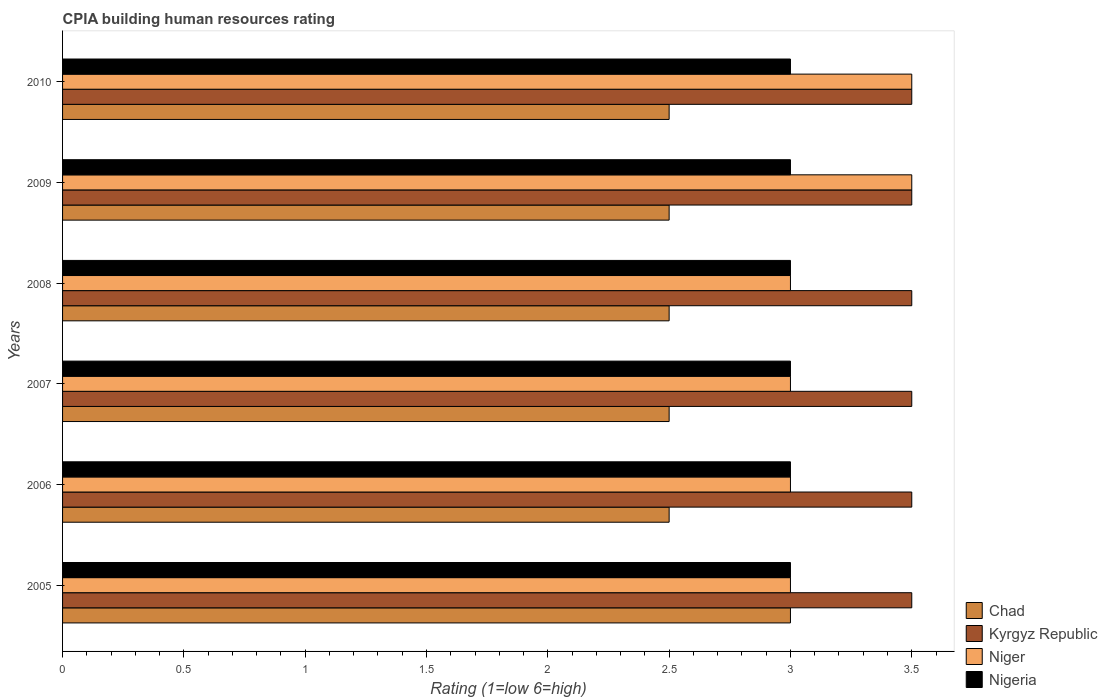How many groups of bars are there?
Ensure brevity in your answer.  6. Are the number of bars on each tick of the Y-axis equal?
Ensure brevity in your answer.  Yes. How many bars are there on the 6th tick from the top?
Provide a short and direct response. 4. In how many cases, is the number of bars for a given year not equal to the number of legend labels?
Offer a terse response. 0. What is the difference between the CPIA rating in Nigeria in 2009 and that in 2010?
Your answer should be compact. 0. What is the difference between the CPIA rating in Nigeria in 2010 and the CPIA rating in Kyrgyz Republic in 2008?
Make the answer very short. -0.5. In the year 2010, what is the difference between the CPIA rating in Niger and CPIA rating in Chad?
Provide a short and direct response. 1. In how many years, is the CPIA rating in Kyrgyz Republic greater than 0.8 ?
Offer a very short reply. 6. What is the ratio of the CPIA rating in Chad in 2005 to that in 2006?
Offer a very short reply. 1.2. What is the difference between the highest and the second highest CPIA rating in Niger?
Your answer should be compact. 0. What is the difference between the highest and the lowest CPIA rating in Niger?
Your answer should be very brief. 0.5. In how many years, is the CPIA rating in Nigeria greater than the average CPIA rating in Nigeria taken over all years?
Offer a very short reply. 0. Is the sum of the CPIA rating in Kyrgyz Republic in 2006 and 2008 greater than the maximum CPIA rating in Nigeria across all years?
Your response must be concise. Yes. Is it the case that in every year, the sum of the CPIA rating in Chad and CPIA rating in Niger is greater than the sum of CPIA rating in Kyrgyz Republic and CPIA rating in Nigeria?
Keep it short and to the point. Yes. What does the 1st bar from the top in 2005 represents?
Make the answer very short. Nigeria. What does the 2nd bar from the bottom in 2008 represents?
Your response must be concise. Kyrgyz Republic. How many bars are there?
Keep it short and to the point. 24. How many years are there in the graph?
Ensure brevity in your answer.  6. Where does the legend appear in the graph?
Give a very brief answer. Bottom right. What is the title of the graph?
Your response must be concise. CPIA building human resources rating. Does "Haiti" appear as one of the legend labels in the graph?
Provide a succinct answer. No. What is the label or title of the X-axis?
Provide a short and direct response. Rating (1=low 6=high). What is the label or title of the Y-axis?
Ensure brevity in your answer.  Years. What is the Rating (1=low 6=high) of Kyrgyz Republic in 2005?
Keep it short and to the point. 3.5. What is the Rating (1=low 6=high) of Kyrgyz Republic in 2006?
Your answer should be very brief. 3.5. What is the Rating (1=low 6=high) of Chad in 2007?
Your answer should be very brief. 2.5. What is the Rating (1=low 6=high) of Niger in 2007?
Offer a terse response. 3. What is the Rating (1=low 6=high) of Nigeria in 2009?
Provide a succinct answer. 3. What is the Rating (1=low 6=high) of Chad in 2010?
Ensure brevity in your answer.  2.5. What is the Rating (1=low 6=high) in Kyrgyz Republic in 2010?
Your answer should be compact. 3.5. Across all years, what is the maximum Rating (1=low 6=high) of Niger?
Make the answer very short. 3.5. Across all years, what is the minimum Rating (1=low 6=high) in Kyrgyz Republic?
Give a very brief answer. 3.5. Across all years, what is the minimum Rating (1=low 6=high) in Niger?
Your answer should be very brief. 3. Across all years, what is the minimum Rating (1=low 6=high) of Nigeria?
Make the answer very short. 3. What is the total Rating (1=low 6=high) of Niger in the graph?
Offer a terse response. 19. What is the difference between the Rating (1=low 6=high) in Chad in 2005 and that in 2007?
Provide a short and direct response. 0.5. What is the difference between the Rating (1=low 6=high) in Kyrgyz Republic in 2005 and that in 2007?
Provide a short and direct response. 0. What is the difference between the Rating (1=low 6=high) of Chad in 2005 and that in 2008?
Your response must be concise. 0.5. What is the difference between the Rating (1=low 6=high) in Kyrgyz Republic in 2005 and that in 2008?
Provide a short and direct response. 0. What is the difference between the Rating (1=low 6=high) in Nigeria in 2005 and that in 2008?
Keep it short and to the point. 0. What is the difference between the Rating (1=low 6=high) of Kyrgyz Republic in 2005 and that in 2009?
Your answer should be compact. 0. What is the difference between the Rating (1=low 6=high) in Chad in 2005 and that in 2010?
Your answer should be very brief. 0.5. What is the difference between the Rating (1=low 6=high) of Niger in 2005 and that in 2010?
Offer a very short reply. -0.5. What is the difference between the Rating (1=low 6=high) of Nigeria in 2005 and that in 2010?
Give a very brief answer. 0. What is the difference between the Rating (1=low 6=high) in Chad in 2006 and that in 2007?
Your response must be concise. 0. What is the difference between the Rating (1=low 6=high) in Kyrgyz Republic in 2006 and that in 2007?
Provide a succinct answer. 0. What is the difference between the Rating (1=low 6=high) in Chad in 2006 and that in 2008?
Ensure brevity in your answer.  0. What is the difference between the Rating (1=low 6=high) of Kyrgyz Republic in 2006 and that in 2008?
Your answer should be compact. 0. What is the difference between the Rating (1=low 6=high) in Niger in 2006 and that in 2008?
Offer a very short reply. 0. What is the difference between the Rating (1=low 6=high) in Nigeria in 2006 and that in 2008?
Provide a succinct answer. 0. What is the difference between the Rating (1=low 6=high) of Kyrgyz Republic in 2006 and that in 2009?
Ensure brevity in your answer.  0. What is the difference between the Rating (1=low 6=high) in Kyrgyz Republic in 2006 and that in 2010?
Your answer should be very brief. 0. What is the difference between the Rating (1=low 6=high) in Nigeria in 2006 and that in 2010?
Your answer should be compact. 0. What is the difference between the Rating (1=low 6=high) in Chad in 2007 and that in 2008?
Your response must be concise. 0. What is the difference between the Rating (1=low 6=high) in Kyrgyz Republic in 2007 and that in 2008?
Provide a succinct answer. 0. What is the difference between the Rating (1=low 6=high) in Niger in 2007 and that in 2008?
Your response must be concise. 0. What is the difference between the Rating (1=low 6=high) in Nigeria in 2007 and that in 2008?
Keep it short and to the point. 0. What is the difference between the Rating (1=low 6=high) of Chad in 2007 and that in 2009?
Offer a very short reply. 0. What is the difference between the Rating (1=low 6=high) in Chad in 2007 and that in 2010?
Your response must be concise. 0. What is the difference between the Rating (1=low 6=high) of Niger in 2007 and that in 2010?
Offer a terse response. -0.5. What is the difference between the Rating (1=low 6=high) in Nigeria in 2007 and that in 2010?
Keep it short and to the point. 0. What is the difference between the Rating (1=low 6=high) in Kyrgyz Republic in 2008 and that in 2009?
Offer a very short reply. 0. What is the difference between the Rating (1=low 6=high) of Niger in 2008 and that in 2009?
Offer a very short reply. -0.5. What is the difference between the Rating (1=low 6=high) in Nigeria in 2008 and that in 2009?
Provide a short and direct response. 0. What is the difference between the Rating (1=low 6=high) of Chad in 2008 and that in 2010?
Provide a succinct answer. 0. What is the difference between the Rating (1=low 6=high) in Kyrgyz Republic in 2008 and that in 2010?
Your answer should be compact. 0. What is the difference between the Rating (1=low 6=high) in Chad in 2009 and that in 2010?
Provide a succinct answer. 0. What is the difference between the Rating (1=low 6=high) of Niger in 2009 and that in 2010?
Make the answer very short. 0. What is the difference between the Rating (1=low 6=high) in Chad in 2005 and the Rating (1=low 6=high) in Kyrgyz Republic in 2006?
Give a very brief answer. -0.5. What is the difference between the Rating (1=low 6=high) in Chad in 2005 and the Rating (1=low 6=high) in Nigeria in 2006?
Ensure brevity in your answer.  0. What is the difference between the Rating (1=low 6=high) in Kyrgyz Republic in 2005 and the Rating (1=low 6=high) in Niger in 2006?
Offer a terse response. 0.5. What is the difference between the Rating (1=low 6=high) of Kyrgyz Republic in 2005 and the Rating (1=low 6=high) of Nigeria in 2006?
Make the answer very short. 0.5. What is the difference between the Rating (1=low 6=high) of Niger in 2005 and the Rating (1=low 6=high) of Nigeria in 2006?
Your answer should be very brief. 0. What is the difference between the Rating (1=low 6=high) in Chad in 2005 and the Rating (1=low 6=high) in Niger in 2007?
Offer a very short reply. 0. What is the difference between the Rating (1=low 6=high) of Chad in 2005 and the Rating (1=low 6=high) of Nigeria in 2007?
Offer a terse response. 0. What is the difference between the Rating (1=low 6=high) in Kyrgyz Republic in 2005 and the Rating (1=low 6=high) in Nigeria in 2007?
Ensure brevity in your answer.  0.5. What is the difference between the Rating (1=low 6=high) of Niger in 2005 and the Rating (1=low 6=high) of Nigeria in 2007?
Provide a succinct answer. 0. What is the difference between the Rating (1=low 6=high) in Chad in 2005 and the Rating (1=low 6=high) in Niger in 2008?
Keep it short and to the point. 0. What is the difference between the Rating (1=low 6=high) of Chad in 2005 and the Rating (1=low 6=high) of Nigeria in 2008?
Make the answer very short. 0. What is the difference between the Rating (1=low 6=high) in Kyrgyz Republic in 2005 and the Rating (1=low 6=high) in Niger in 2008?
Offer a very short reply. 0.5. What is the difference between the Rating (1=low 6=high) in Kyrgyz Republic in 2005 and the Rating (1=low 6=high) in Nigeria in 2008?
Keep it short and to the point. 0.5. What is the difference between the Rating (1=low 6=high) in Niger in 2005 and the Rating (1=low 6=high) in Nigeria in 2008?
Ensure brevity in your answer.  0. What is the difference between the Rating (1=low 6=high) of Chad in 2005 and the Rating (1=low 6=high) of Niger in 2009?
Offer a very short reply. -0.5. What is the difference between the Rating (1=low 6=high) in Chad in 2005 and the Rating (1=low 6=high) in Nigeria in 2009?
Offer a terse response. 0. What is the difference between the Rating (1=low 6=high) of Kyrgyz Republic in 2005 and the Rating (1=low 6=high) of Nigeria in 2009?
Give a very brief answer. 0.5. What is the difference between the Rating (1=low 6=high) of Chad in 2005 and the Rating (1=low 6=high) of Kyrgyz Republic in 2010?
Your answer should be compact. -0.5. What is the difference between the Rating (1=low 6=high) in Chad in 2005 and the Rating (1=low 6=high) in Nigeria in 2010?
Provide a succinct answer. 0. What is the difference between the Rating (1=low 6=high) in Kyrgyz Republic in 2005 and the Rating (1=low 6=high) in Niger in 2010?
Your response must be concise. 0. What is the difference between the Rating (1=low 6=high) in Niger in 2005 and the Rating (1=low 6=high) in Nigeria in 2010?
Provide a succinct answer. 0. What is the difference between the Rating (1=low 6=high) in Chad in 2006 and the Rating (1=low 6=high) in Kyrgyz Republic in 2007?
Offer a terse response. -1. What is the difference between the Rating (1=low 6=high) in Kyrgyz Republic in 2006 and the Rating (1=low 6=high) in Niger in 2007?
Provide a short and direct response. 0.5. What is the difference between the Rating (1=low 6=high) in Kyrgyz Republic in 2006 and the Rating (1=low 6=high) in Nigeria in 2007?
Offer a very short reply. 0.5. What is the difference between the Rating (1=low 6=high) in Chad in 2006 and the Rating (1=low 6=high) in Niger in 2008?
Your response must be concise. -0.5. What is the difference between the Rating (1=low 6=high) of Chad in 2006 and the Rating (1=low 6=high) of Nigeria in 2008?
Your answer should be very brief. -0.5. What is the difference between the Rating (1=low 6=high) of Kyrgyz Republic in 2006 and the Rating (1=low 6=high) of Nigeria in 2008?
Provide a succinct answer. 0.5. What is the difference between the Rating (1=low 6=high) in Chad in 2006 and the Rating (1=low 6=high) in Niger in 2009?
Your response must be concise. -1. What is the difference between the Rating (1=low 6=high) in Chad in 2006 and the Rating (1=low 6=high) in Nigeria in 2009?
Make the answer very short. -0.5. What is the difference between the Rating (1=low 6=high) of Chad in 2006 and the Rating (1=low 6=high) of Kyrgyz Republic in 2010?
Your response must be concise. -1. What is the difference between the Rating (1=low 6=high) of Kyrgyz Republic in 2006 and the Rating (1=low 6=high) of Niger in 2010?
Offer a very short reply. 0. What is the difference between the Rating (1=low 6=high) in Chad in 2007 and the Rating (1=low 6=high) in Kyrgyz Republic in 2008?
Make the answer very short. -1. What is the difference between the Rating (1=low 6=high) in Chad in 2007 and the Rating (1=low 6=high) in Niger in 2008?
Provide a succinct answer. -0.5. What is the difference between the Rating (1=low 6=high) in Chad in 2007 and the Rating (1=low 6=high) in Nigeria in 2008?
Give a very brief answer. -0.5. What is the difference between the Rating (1=low 6=high) in Kyrgyz Republic in 2007 and the Rating (1=low 6=high) in Niger in 2008?
Ensure brevity in your answer.  0.5. What is the difference between the Rating (1=low 6=high) in Kyrgyz Republic in 2007 and the Rating (1=low 6=high) in Nigeria in 2008?
Give a very brief answer. 0.5. What is the difference between the Rating (1=low 6=high) in Chad in 2007 and the Rating (1=low 6=high) in Nigeria in 2009?
Make the answer very short. -0.5. What is the difference between the Rating (1=low 6=high) in Kyrgyz Republic in 2007 and the Rating (1=low 6=high) in Niger in 2009?
Make the answer very short. 0. What is the difference between the Rating (1=low 6=high) of Chad in 2007 and the Rating (1=low 6=high) of Kyrgyz Republic in 2010?
Provide a short and direct response. -1. What is the difference between the Rating (1=low 6=high) in Chad in 2007 and the Rating (1=low 6=high) in Niger in 2010?
Make the answer very short. -1. What is the difference between the Rating (1=low 6=high) in Chad in 2007 and the Rating (1=low 6=high) in Nigeria in 2010?
Your answer should be very brief. -0.5. What is the difference between the Rating (1=low 6=high) in Kyrgyz Republic in 2007 and the Rating (1=low 6=high) in Niger in 2010?
Give a very brief answer. 0. What is the difference between the Rating (1=low 6=high) in Niger in 2007 and the Rating (1=low 6=high) in Nigeria in 2010?
Keep it short and to the point. 0. What is the difference between the Rating (1=low 6=high) of Chad in 2008 and the Rating (1=low 6=high) of Nigeria in 2009?
Provide a succinct answer. -0.5. What is the difference between the Rating (1=low 6=high) of Kyrgyz Republic in 2008 and the Rating (1=low 6=high) of Niger in 2009?
Provide a short and direct response. 0. What is the difference between the Rating (1=low 6=high) in Kyrgyz Republic in 2008 and the Rating (1=low 6=high) in Nigeria in 2009?
Offer a very short reply. 0.5. What is the difference between the Rating (1=low 6=high) of Niger in 2008 and the Rating (1=low 6=high) of Nigeria in 2009?
Provide a short and direct response. 0. What is the difference between the Rating (1=low 6=high) of Kyrgyz Republic in 2008 and the Rating (1=low 6=high) of Nigeria in 2010?
Offer a very short reply. 0.5. What is the difference between the Rating (1=low 6=high) in Chad in 2009 and the Rating (1=low 6=high) in Nigeria in 2010?
Provide a succinct answer. -0.5. What is the difference between the Rating (1=low 6=high) of Kyrgyz Republic in 2009 and the Rating (1=low 6=high) of Niger in 2010?
Your response must be concise. 0. What is the average Rating (1=low 6=high) in Chad per year?
Your answer should be compact. 2.58. What is the average Rating (1=low 6=high) in Kyrgyz Republic per year?
Provide a succinct answer. 3.5. What is the average Rating (1=low 6=high) of Niger per year?
Your response must be concise. 3.17. What is the average Rating (1=low 6=high) in Nigeria per year?
Make the answer very short. 3. In the year 2005, what is the difference between the Rating (1=low 6=high) of Chad and Rating (1=low 6=high) of Nigeria?
Provide a succinct answer. 0. In the year 2005, what is the difference between the Rating (1=low 6=high) in Kyrgyz Republic and Rating (1=low 6=high) in Niger?
Give a very brief answer. 0.5. In the year 2005, what is the difference between the Rating (1=low 6=high) of Kyrgyz Republic and Rating (1=low 6=high) of Nigeria?
Ensure brevity in your answer.  0.5. In the year 2005, what is the difference between the Rating (1=low 6=high) of Niger and Rating (1=low 6=high) of Nigeria?
Offer a terse response. 0. In the year 2006, what is the difference between the Rating (1=low 6=high) of Chad and Rating (1=low 6=high) of Kyrgyz Republic?
Offer a terse response. -1. In the year 2006, what is the difference between the Rating (1=low 6=high) in Kyrgyz Republic and Rating (1=low 6=high) in Nigeria?
Provide a succinct answer. 0.5. In the year 2007, what is the difference between the Rating (1=low 6=high) in Chad and Rating (1=low 6=high) in Kyrgyz Republic?
Offer a very short reply. -1. In the year 2007, what is the difference between the Rating (1=low 6=high) of Chad and Rating (1=low 6=high) of Niger?
Your response must be concise. -0.5. In the year 2007, what is the difference between the Rating (1=low 6=high) in Kyrgyz Republic and Rating (1=low 6=high) in Niger?
Your answer should be very brief. 0.5. In the year 2007, what is the difference between the Rating (1=low 6=high) in Kyrgyz Republic and Rating (1=low 6=high) in Nigeria?
Your answer should be very brief. 0.5. In the year 2008, what is the difference between the Rating (1=low 6=high) in Chad and Rating (1=low 6=high) in Kyrgyz Republic?
Give a very brief answer. -1. In the year 2008, what is the difference between the Rating (1=low 6=high) in Kyrgyz Republic and Rating (1=low 6=high) in Nigeria?
Give a very brief answer. 0.5. In the year 2008, what is the difference between the Rating (1=low 6=high) in Niger and Rating (1=low 6=high) in Nigeria?
Keep it short and to the point. 0. In the year 2009, what is the difference between the Rating (1=low 6=high) of Chad and Rating (1=low 6=high) of Kyrgyz Republic?
Offer a terse response. -1. In the year 2009, what is the difference between the Rating (1=low 6=high) of Chad and Rating (1=low 6=high) of Niger?
Make the answer very short. -1. In the year 2009, what is the difference between the Rating (1=low 6=high) in Kyrgyz Republic and Rating (1=low 6=high) in Nigeria?
Offer a terse response. 0.5. In the year 2010, what is the difference between the Rating (1=low 6=high) in Chad and Rating (1=low 6=high) in Niger?
Ensure brevity in your answer.  -1. In the year 2010, what is the difference between the Rating (1=low 6=high) of Chad and Rating (1=low 6=high) of Nigeria?
Your response must be concise. -0.5. What is the ratio of the Rating (1=low 6=high) of Kyrgyz Republic in 2005 to that in 2006?
Make the answer very short. 1. What is the ratio of the Rating (1=low 6=high) of Niger in 2005 to that in 2006?
Your answer should be very brief. 1. What is the ratio of the Rating (1=low 6=high) in Chad in 2005 to that in 2007?
Provide a short and direct response. 1.2. What is the ratio of the Rating (1=low 6=high) of Kyrgyz Republic in 2005 to that in 2008?
Your answer should be very brief. 1. What is the ratio of the Rating (1=low 6=high) of Nigeria in 2005 to that in 2008?
Provide a short and direct response. 1. What is the ratio of the Rating (1=low 6=high) of Kyrgyz Republic in 2005 to that in 2009?
Provide a succinct answer. 1. What is the ratio of the Rating (1=low 6=high) of Niger in 2005 to that in 2009?
Ensure brevity in your answer.  0.86. What is the ratio of the Rating (1=low 6=high) of Chad in 2005 to that in 2010?
Keep it short and to the point. 1.2. What is the ratio of the Rating (1=low 6=high) of Kyrgyz Republic in 2005 to that in 2010?
Your answer should be very brief. 1. What is the ratio of the Rating (1=low 6=high) of Chad in 2006 to that in 2007?
Keep it short and to the point. 1. What is the ratio of the Rating (1=low 6=high) of Niger in 2006 to that in 2007?
Offer a terse response. 1. What is the ratio of the Rating (1=low 6=high) in Nigeria in 2006 to that in 2007?
Your answer should be very brief. 1. What is the ratio of the Rating (1=low 6=high) of Kyrgyz Republic in 2006 to that in 2009?
Make the answer very short. 1. What is the ratio of the Rating (1=low 6=high) of Niger in 2006 to that in 2009?
Give a very brief answer. 0.86. What is the ratio of the Rating (1=low 6=high) in Nigeria in 2006 to that in 2009?
Provide a short and direct response. 1. What is the ratio of the Rating (1=low 6=high) of Chad in 2006 to that in 2010?
Offer a very short reply. 1. What is the ratio of the Rating (1=low 6=high) of Nigeria in 2006 to that in 2010?
Offer a very short reply. 1. What is the ratio of the Rating (1=low 6=high) in Kyrgyz Republic in 2007 to that in 2008?
Offer a very short reply. 1. What is the ratio of the Rating (1=low 6=high) in Niger in 2007 to that in 2008?
Provide a short and direct response. 1. What is the ratio of the Rating (1=low 6=high) in Kyrgyz Republic in 2007 to that in 2009?
Offer a terse response. 1. What is the ratio of the Rating (1=low 6=high) of Nigeria in 2007 to that in 2009?
Give a very brief answer. 1. What is the ratio of the Rating (1=low 6=high) of Kyrgyz Republic in 2007 to that in 2010?
Provide a short and direct response. 1. What is the ratio of the Rating (1=low 6=high) of Nigeria in 2007 to that in 2010?
Offer a terse response. 1. What is the ratio of the Rating (1=low 6=high) in Niger in 2008 to that in 2009?
Give a very brief answer. 0.86. What is the ratio of the Rating (1=low 6=high) of Chad in 2008 to that in 2010?
Offer a very short reply. 1. What is the ratio of the Rating (1=low 6=high) in Kyrgyz Republic in 2008 to that in 2010?
Keep it short and to the point. 1. What is the ratio of the Rating (1=low 6=high) in Niger in 2008 to that in 2010?
Provide a short and direct response. 0.86. What is the ratio of the Rating (1=low 6=high) of Nigeria in 2008 to that in 2010?
Offer a terse response. 1. What is the ratio of the Rating (1=low 6=high) of Niger in 2009 to that in 2010?
Your response must be concise. 1. What is the ratio of the Rating (1=low 6=high) of Nigeria in 2009 to that in 2010?
Give a very brief answer. 1. What is the difference between the highest and the second highest Rating (1=low 6=high) in Niger?
Offer a terse response. 0. What is the difference between the highest and the lowest Rating (1=low 6=high) in Chad?
Make the answer very short. 0.5. What is the difference between the highest and the lowest Rating (1=low 6=high) of Kyrgyz Republic?
Your answer should be very brief. 0. What is the difference between the highest and the lowest Rating (1=low 6=high) in Niger?
Offer a very short reply. 0.5. What is the difference between the highest and the lowest Rating (1=low 6=high) of Nigeria?
Keep it short and to the point. 0. 